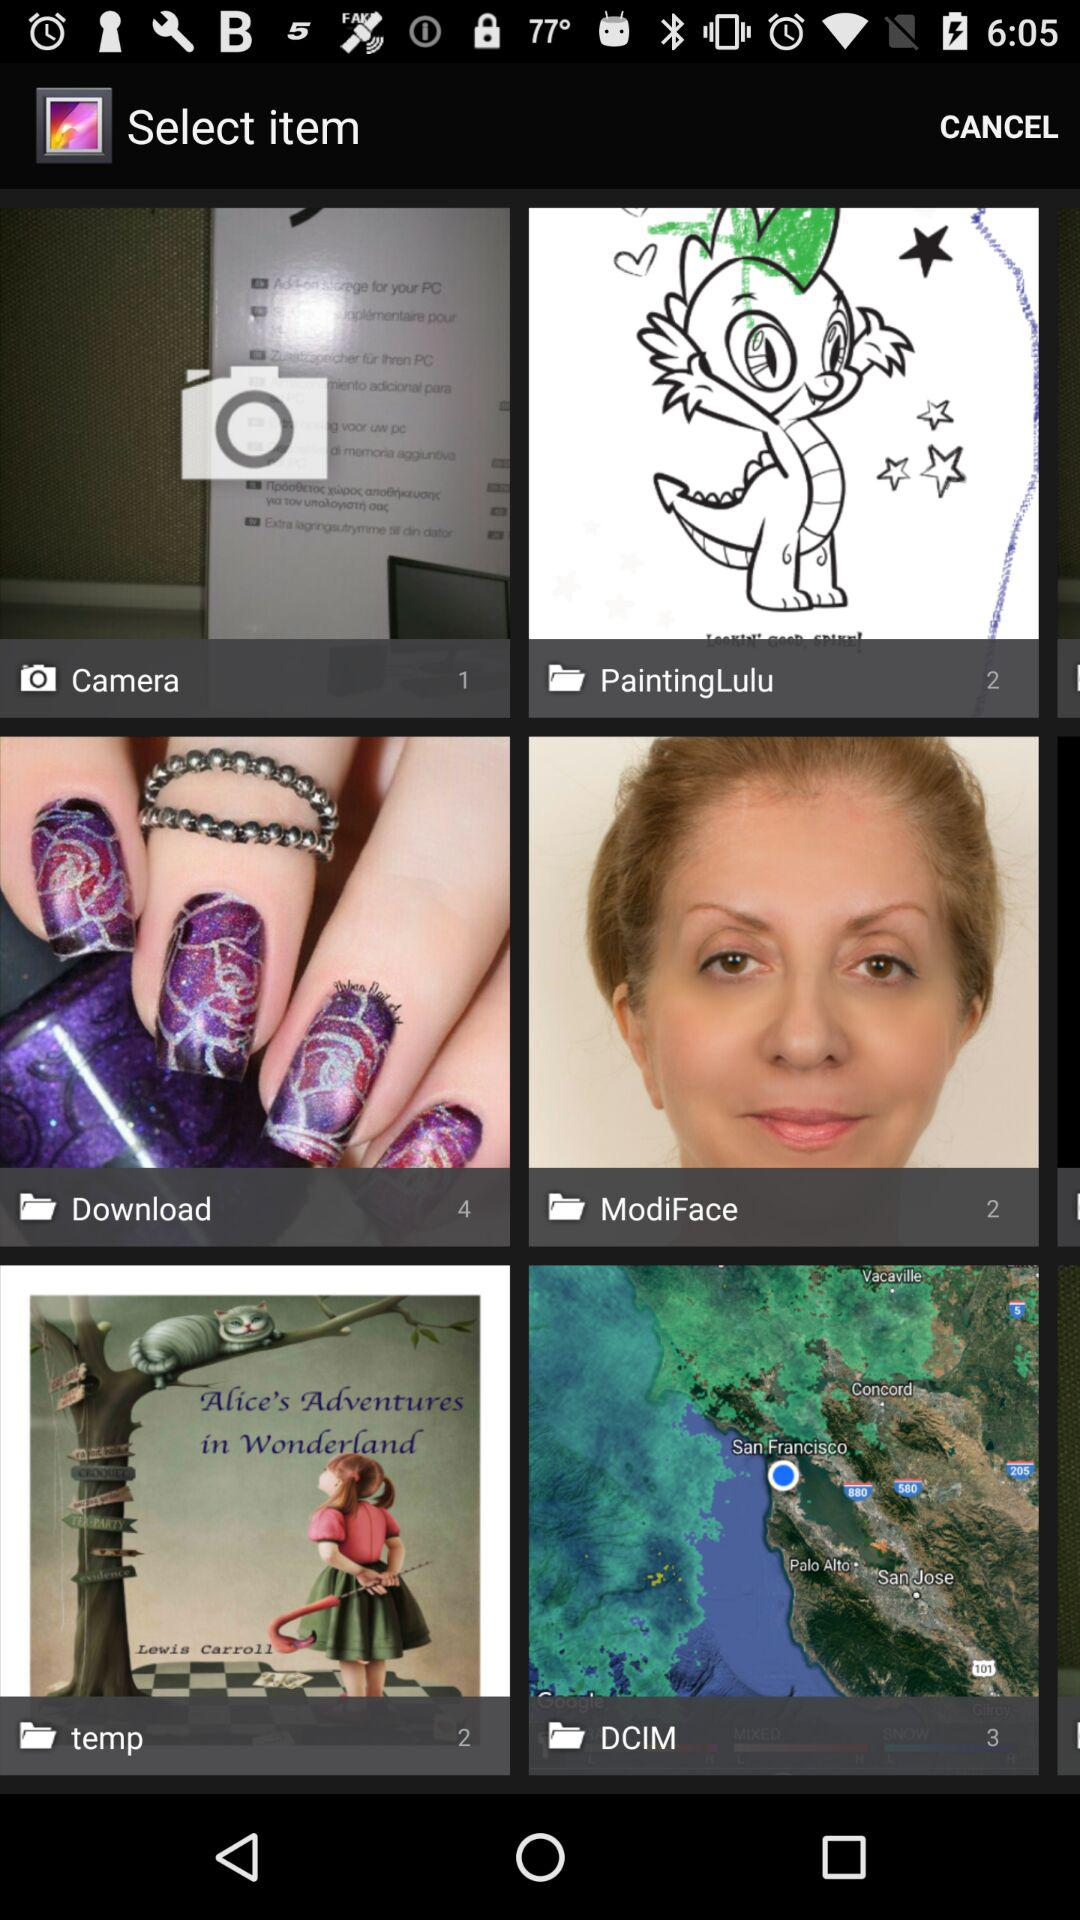In which folder there are 4 images? Four images are in the "Download" folder. 